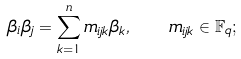Convert formula to latex. <formula><loc_0><loc_0><loc_500><loc_500>\beta _ { i } \beta _ { j } = \sum _ { k = 1 } ^ { n } m _ { i j k } \beta _ { k } , \quad m _ { i j k } \in \mathbb { F } _ { q } ;</formula> 